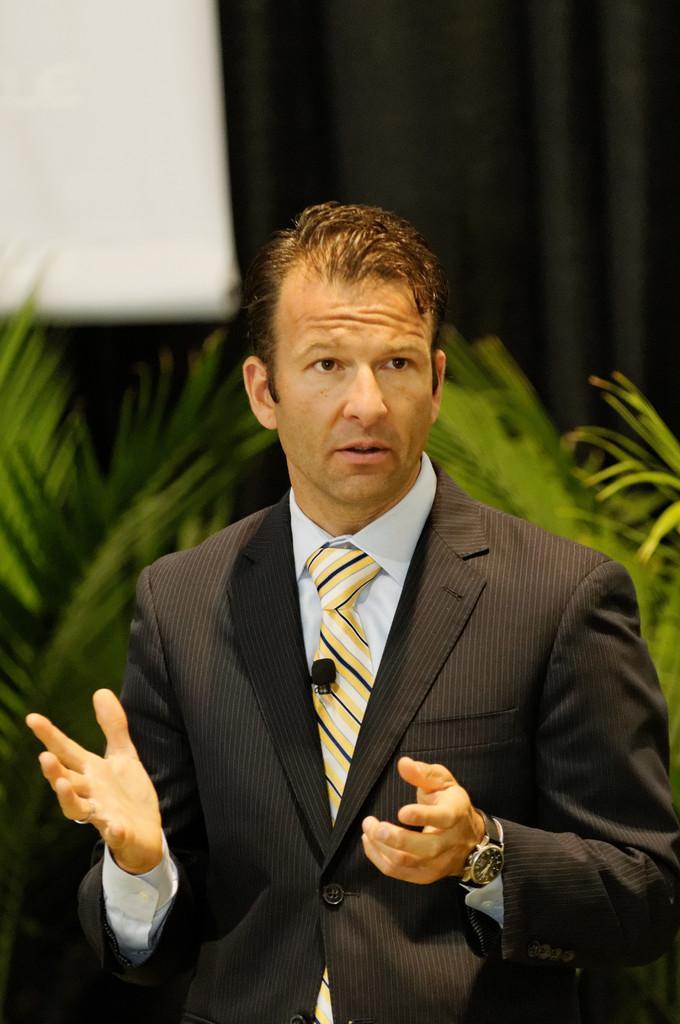Can you describe this image briefly? In this picture there is a man who is wearing suit and watch. In the suit we can see a small mic, behind him we can see the plants. In the top left corner there is a projector screen. In the top right we can see the black cloth. 